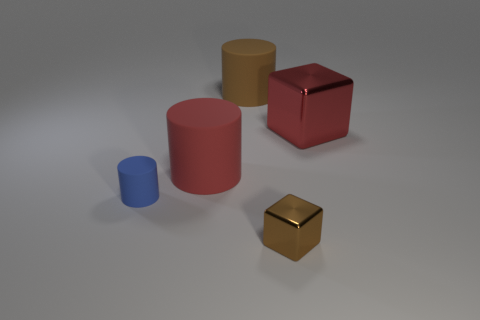What is the texture of the objects displayed? The objects appear to have different textures. The red matte cube has a non-reflective surface, the blue cylinder has a slightly reflective matte finish, the gold cube has a reflective, shiny surface, and the yellow cylinder has a less reflective, matte surface. 